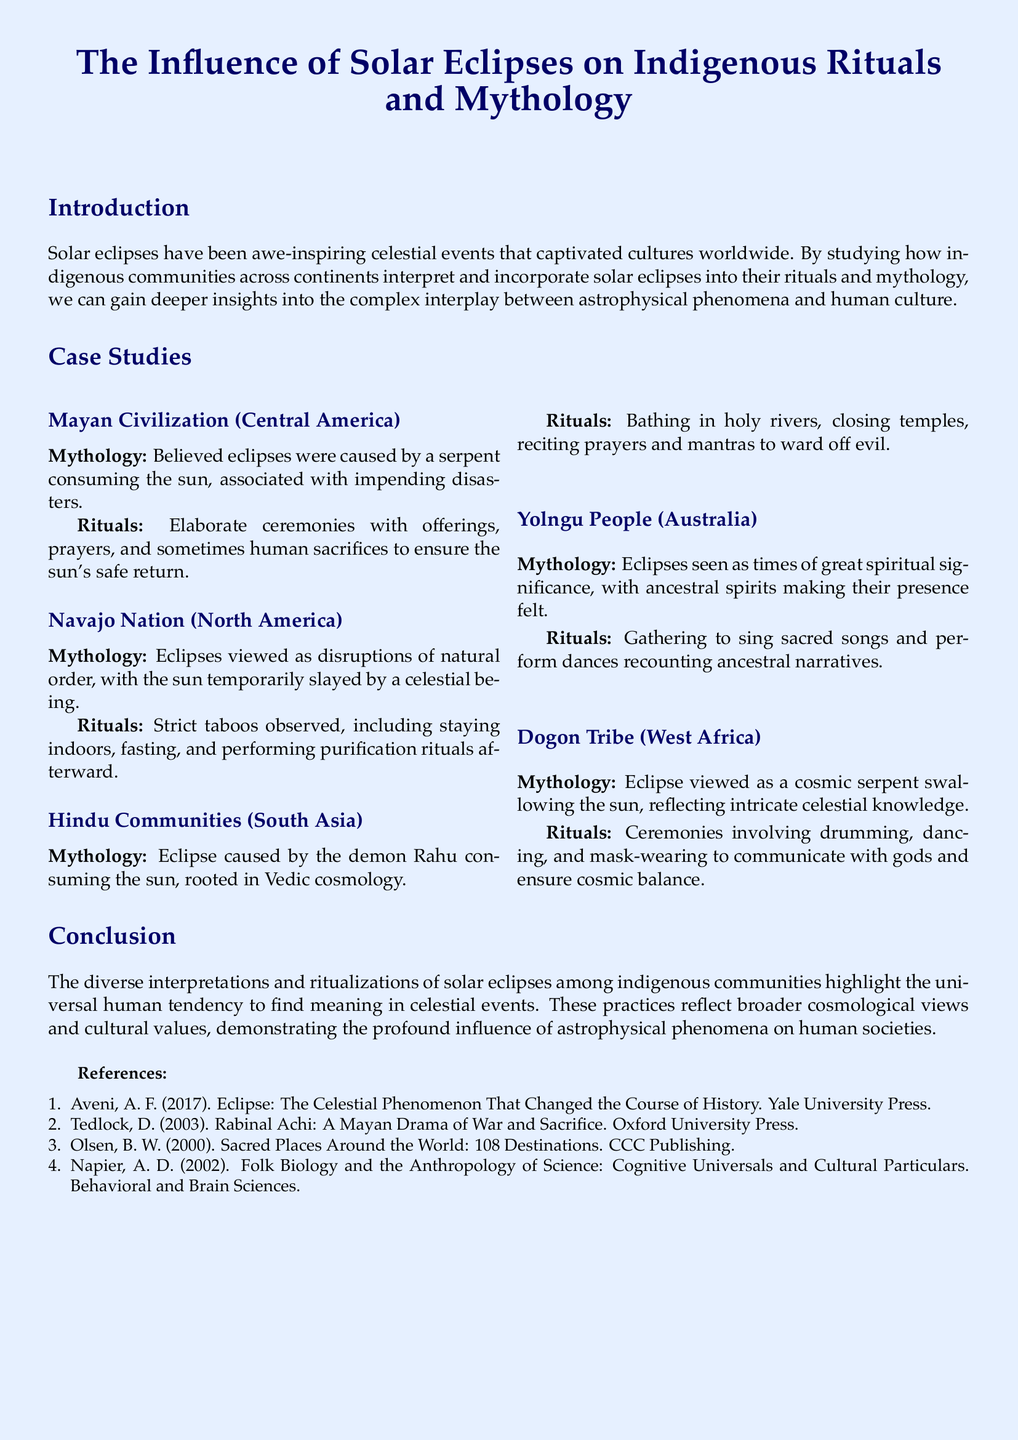What is the focus of the case study? The focus of the case study is about the influence of solar eclipses on indigenous rituals and mythology across various communities.
Answer: Influence of solar eclipses on indigenous rituals and mythology Which indigenous community is associated with the serpent consuming the sun? According to the case study, the Mayan civilization believed that the eclipse was caused by a serpent consuming the sun.
Answer: Mayan Civilization What do the Yolngu people do during a solar eclipse? The Yolngu people gather to sing sacred songs and perform dances recounting ancestral narratives during a solar eclipse.
Answer: Sing sacred songs and perform dances What celestial being temporarily slays the sun in Navajo mythology? In Navajo mythology, the sun is temporarily slayed by a celestial being during an eclipse.
Answer: Celestial being How many indigenous communities are discussed in the case study? The case study covers five indigenous communities in relation to solar eclipses.
Answer: Five What common action is taken by Hindu communities during a solar eclipse? Hindu communities bathe in holy rivers during a solar eclipse as part of their rituals.
Answer: Bathing in holy rivers Which tribe views the eclipse as a cosmic serpent swallowing the sun? The Dogon tribe views the eclipse as a cosmic serpent swallowing the sun.
Answer: Dogon Tribe What do the rituals performed by the Dogon Tribe often include? The rituals performed by the Dogon Tribe often include drumming, dancing, and mask-wearing.
Answer: Drumming, dancing, and mask-wearing 